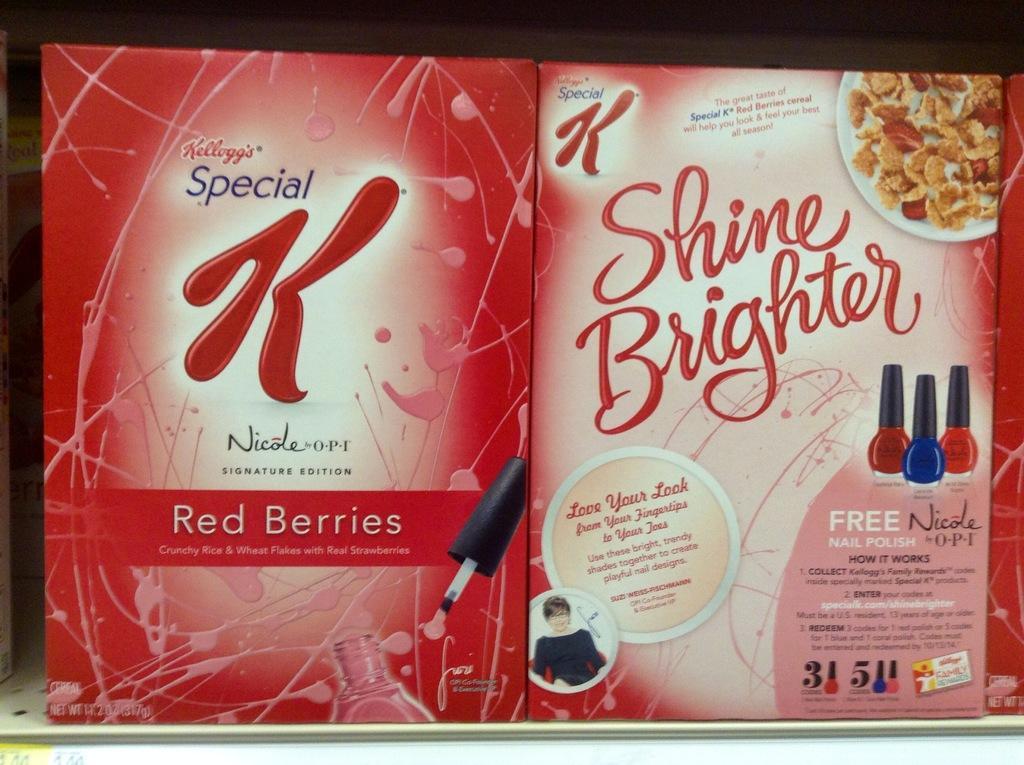Describe this image in one or two sentences. In this picture we can see two posters,on this posters we can see some text,person,food items and nail polishes. 